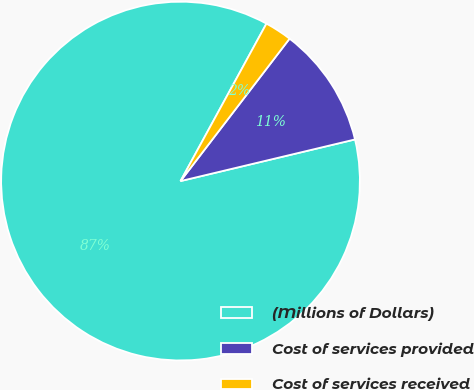Convert chart to OTSL. <chart><loc_0><loc_0><loc_500><loc_500><pie_chart><fcel>(Millions of Dollars)<fcel>Cost of services provided<fcel>Cost of services received<nl><fcel>86.67%<fcel>10.87%<fcel>2.45%<nl></chart> 